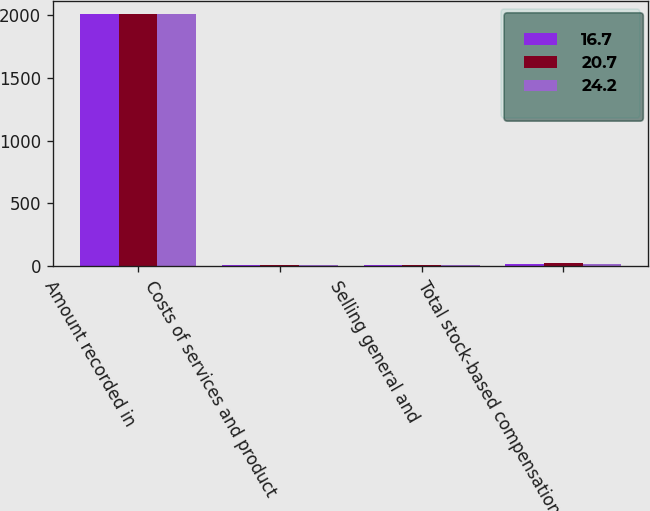Convert chart. <chart><loc_0><loc_0><loc_500><loc_500><stacked_bar_chart><ecel><fcel>Amount recorded in<fcel>Costs of services and product<fcel>Selling general and<fcel>Total stock-based compensation<nl><fcel>16.7<fcel>2008<fcel>9.6<fcel>11.1<fcel>20.7<nl><fcel>20.7<fcel>2007<fcel>10.8<fcel>13.4<fcel>24.2<nl><fcel>24.2<fcel>2006<fcel>8.2<fcel>8.5<fcel>16.7<nl></chart> 